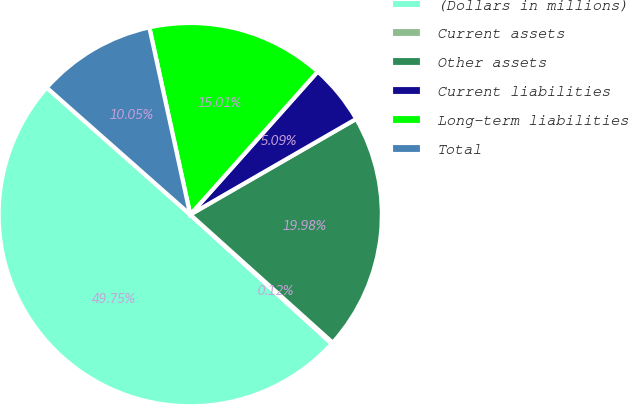Convert chart to OTSL. <chart><loc_0><loc_0><loc_500><loc_500><pie_chart><fcel>(Dollars in millions)<fcel>Current assets<fcel>Other assets<fcel>Current liabilities<fcel>Long-term liabilities<fcel>Total<nl><fcel>49.75%<fcel>0.12%<fcel>19.98%<fcel>5.09%<fcel>15.01%<fcel>10.05%<nl></chart> 